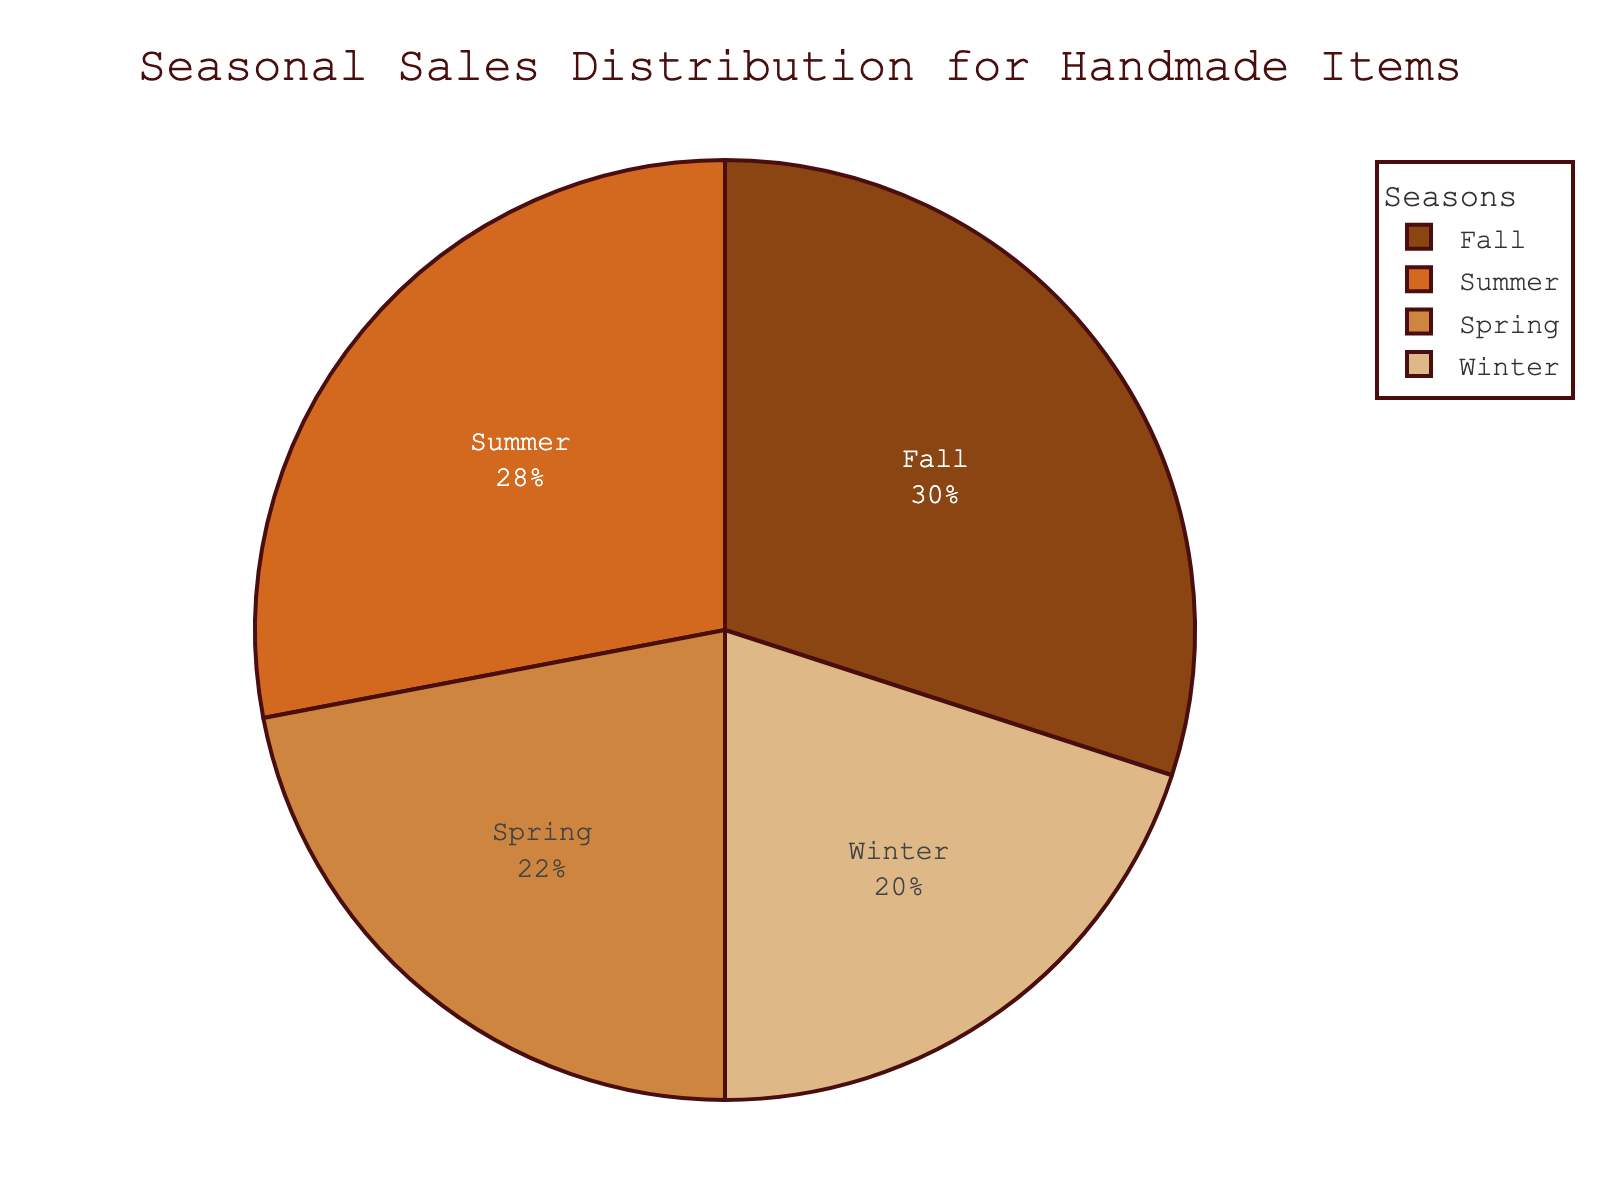What's the season with the highest percentage of sales? To determine the season with the highest percentage of sales, we look for the largest value in the pie chart. According to the data, Fall has the highest percentage at 30%.
Answer: Fall What percentage of sales occur in Winter? To find the percentage of sales for Winter, we locate the Winter segment and read the value displayed, which is 20%.
Answer: 20% Is the percentage of sales in Spring greater than in Winter? Compare the sales percentages of Spring and Winter. Spring has 22%, and Winter has 20%. Since 22% is greater than 20%, the statement is true.
Answer: Yes How much more is the percentage of sales in Fall compared to Spring? Subtract the Spring percentage (22%) from the Fall percentage (30%) to find the difference: 30% - 22% = 8%.
Answer: 8% If we combine the sales percentages of Spring and Winter, what is the result? Add the percentages for Spring (22%) and Winter (20%): 22% + 20% = 42%.
Answer: 42% Which season has the second lowest percentage of sales? To identify the second lowest percentage, we order the percentages from lowest to highest: Winter (20%), Spring (22%), Summer (28%), Fall (30%). The second lowest is Spring with 22%.
Answer: Spring How does the percentage of sales in Summer compare to that in Fall? Compare the percentages: Summer has 28%, and Fall has 30%. Since 28% is less than 30%, Summer's percentage is lower than Fall's.
Answer: Less than What is the color associated with the season Summer in the pie chart? To find the color associated with Summer, look at the pie chart legend. The color for Summer is typically a medium brown.
Answer: Medium brown Are the combined sales percentages of Spring and Summer greater than Fall's sales percentage? First, combine Spring (22%) and Summer (28%): 22% + 28% = 50%. Compare this to Fall's 30%, and since 50% is greater than 30%, the combined percentage is greater.
Answer: Yes What's the average sales percentage across all four seasons? Calculate the average by summing all percentages and dividing by the number of seasons: (22% + 28% + 30% + 20%) / 4 = 100 / 4 = 25%.
Answer: 25% 